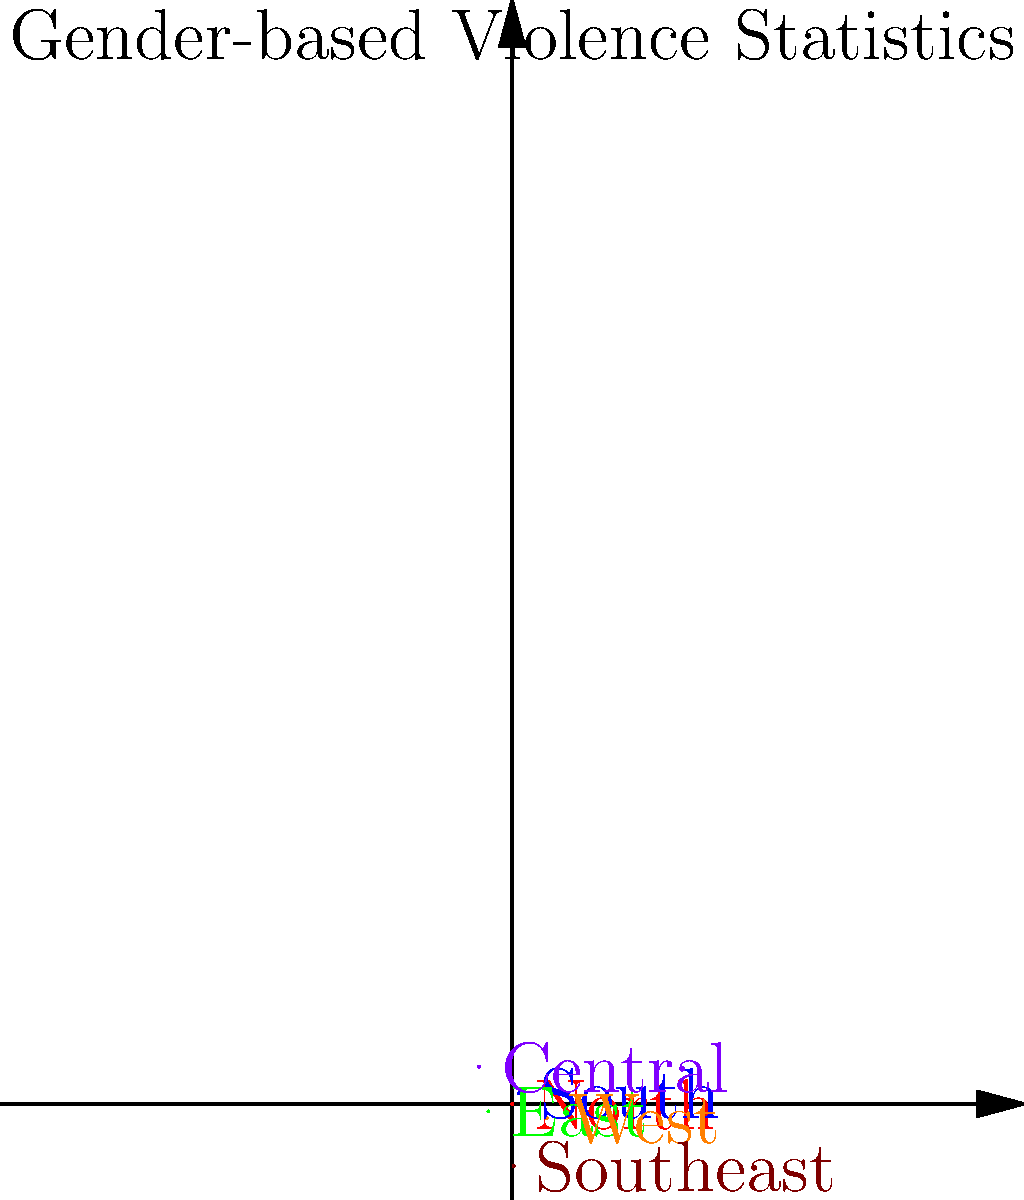In the rose diagram representing gender-based violence statistics across different regions, which region shows the highest prevalence of such violence? How might this information be valuable for an anthropologist studying gender-based issues in society? To answer this question, we need to analyze the rose diagram:

1. Identify the regions: North, South, East, West, Central, and Southeast.
2. Compare the length of each "petal" in the diagram:
   - North (red): approximately 30 units
   - South (blue): approximately 45 units
   - East (green): approximately 60 units
   - West (orange): approximately 75 units
   - Central (purple): approximately 40 units
   - Southeast (brown): approximately 55 units

3. The longest petal represents the highest prevalence of gender-based violence.
4. The West region has the longest petal, measuring about 75 units.

For an anthropologist studying gender-based issues:

1. This data provides a comparative view of gender-based violence across regions.
2. It helps identify areas that require more focused research and intervention.
3. The information can be used to:
   a. Analyze cultural, social, and economic factors contributing to higher rates in certain regions.
   b. Develop targeted strategies for addressing gender-based violence.
   c. Conduct cross-cultural comparisons to understand varying dynamics of gender relations.
   d. Inform policy recommendations for reducing gender-based violence.

4. The visual representation allows for quick identification of patterns and disparities, which is crucial for anthropological analysis.
Answer: West region; valuable for identifying regional patterns, focusing research, and informing intervention strategies. 